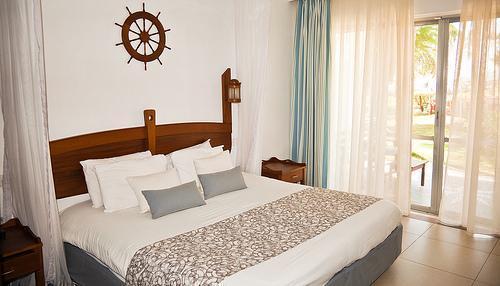How many beds are there?
Give a very brief answer. 1. 